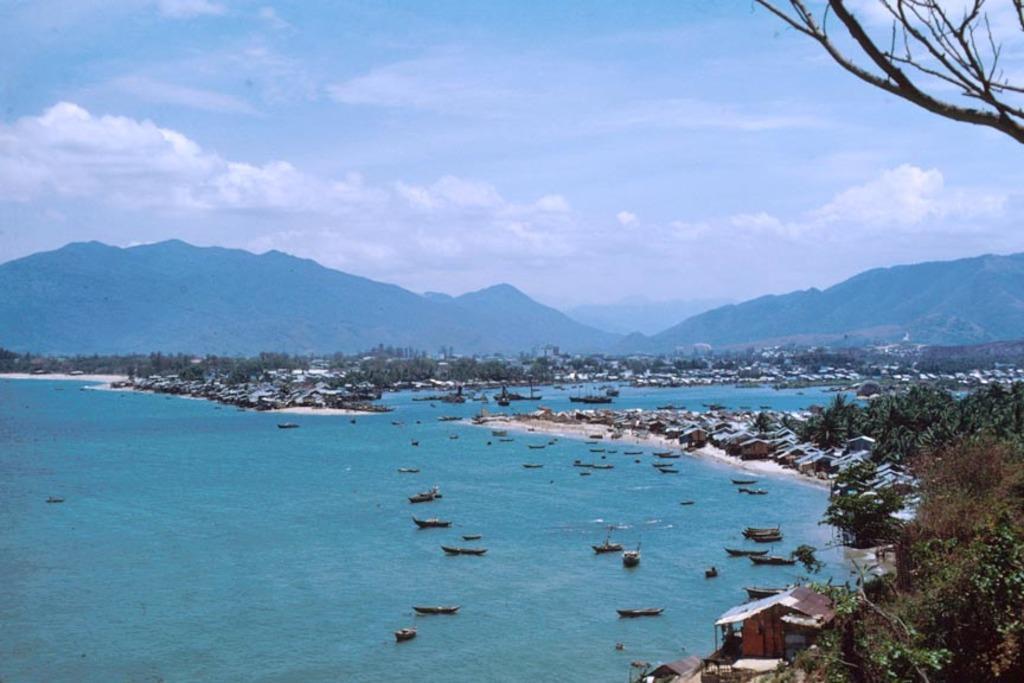Please provide a concise description of this image. In this image we can see the sea. There are many watercraft in the image. There are many trees and plants in the image. We can see the clouds in the sky. There are many houses in the image. There are many hills in the image. 